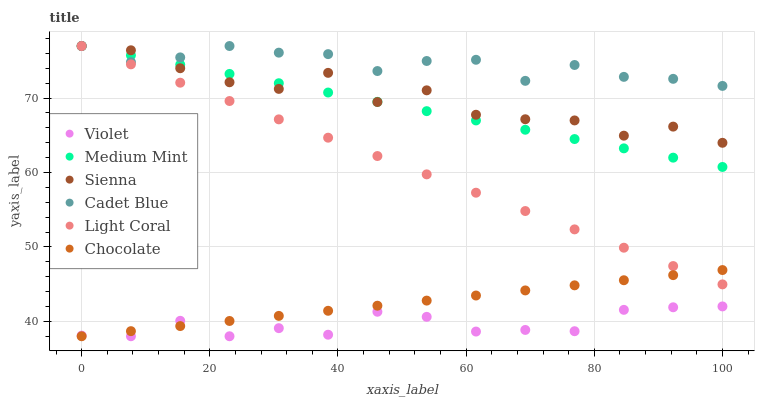Does Violet have the minimum area under the curve?
Answer yes or no. Yes. Does Cadet Blue have the maximum area under the curve?
Answer yes or no. Yes. Does Light Coral have the minimum area under the curve?
Answer yes or no. No. Does Light Coral have the maximum area under the curve?
Answer yes or no. No. Is Chocolate the smoothest?
Answer yes or no. Yes. Is Sienna the roughest?
Answer yes or no. Yes. Is Light Coral the smoothest?
Answer yes or no. No. Is Light Coral the roughest?
Answer yes or no. No. Does Chocolate have the lowest value?
Answer yes or no. Yes. Does Light Coral have the lowest value?
Answer yes or no. No. Does Sienna have the highest value?
Answer yes or no. Yes. Does Chocolate have the highest value?
Answer yes or no. No. Is Chocolate less than Sienna?
Answer yes or no. Yes. Is Cadet Blue greater than Violet?
Answer yes or no. Yes. Does Violet intersect Chocolate?
Answer yes or no. Yes. Is Violet less than Chocolate?
Answer yes or no. No. Is Violet greater than Chocolate?
Answer yes or no. No. Does Chocolate intersect Sienna?
Answer yes or no. No. 